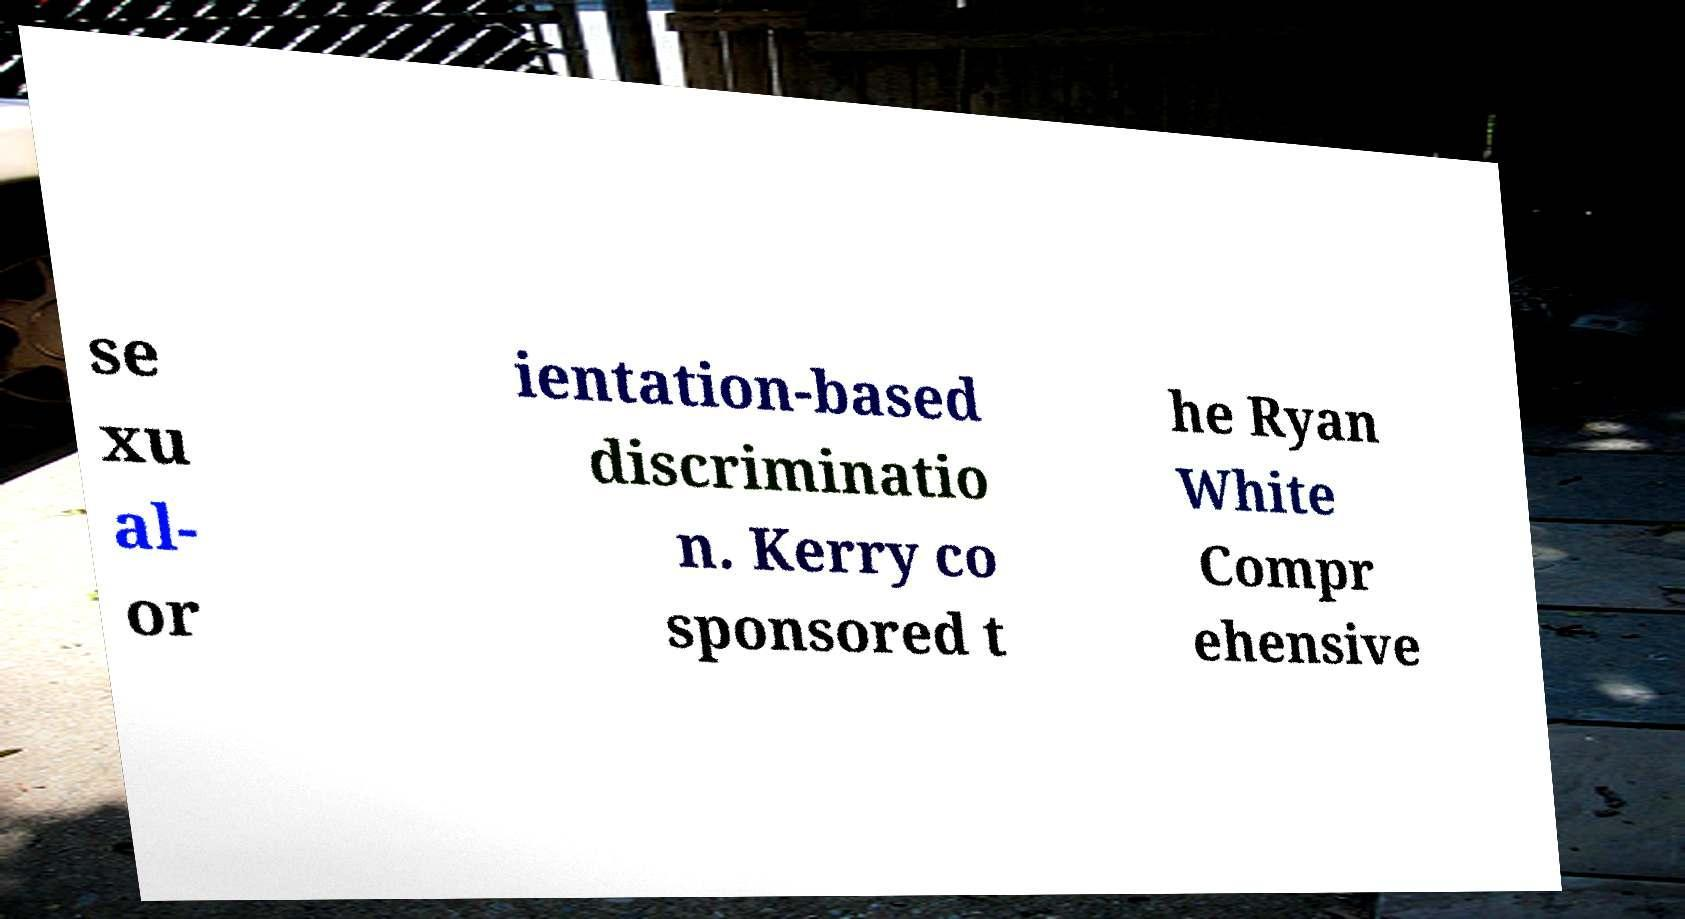Can you accurately transcribe the text from the provided image for me? se xu al- or ientation-based discriminatio n. Kerry co sponsored t he Ryan White Compr ehensive 